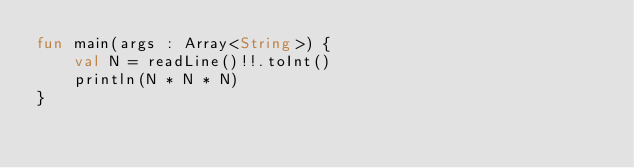<code> <loc_0><loc_0><loc_500><loc_500><_Kotlin_>fun main(args : Array<String>) {
    val N = readLine()!!.toInt()
    println(N * N * N)
}</code> 